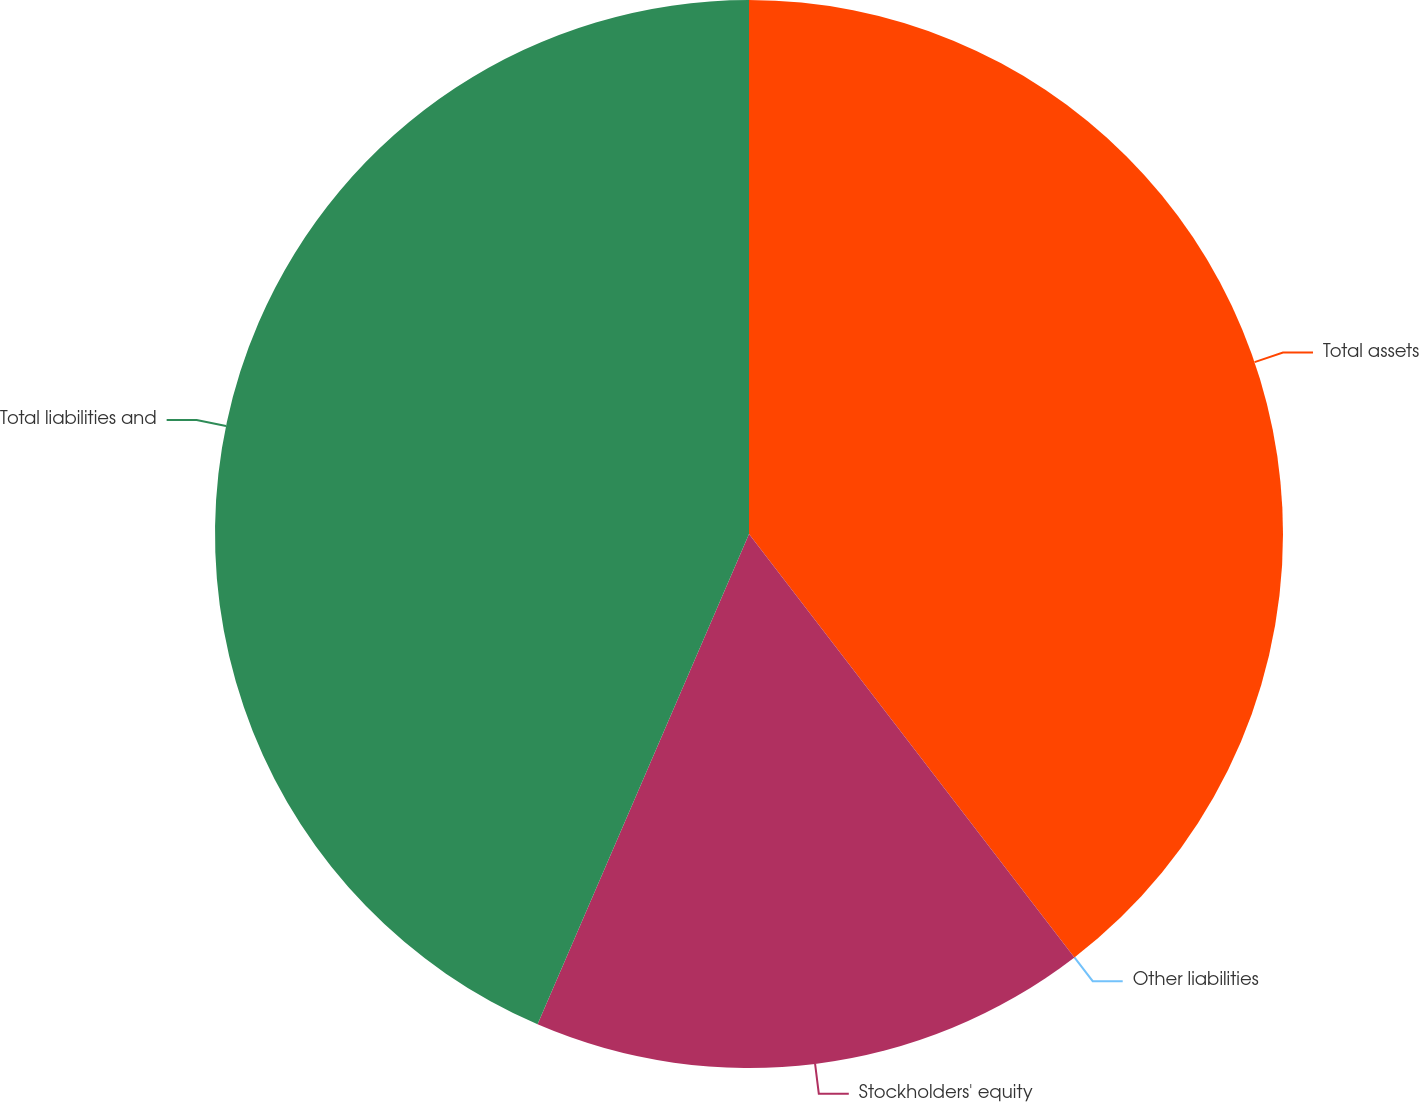<chart> <loc_0><loc_0><loc_500><loc_500><pie_chart><fcel>Total assets<fcel>Other liabilities<fcel>Stockholders' equity<fcel>Total liabilities and<nl><fcel>39.57%<fcel>0.0%<fcel>16.91%<fcel>43.52%<nl></chart> 